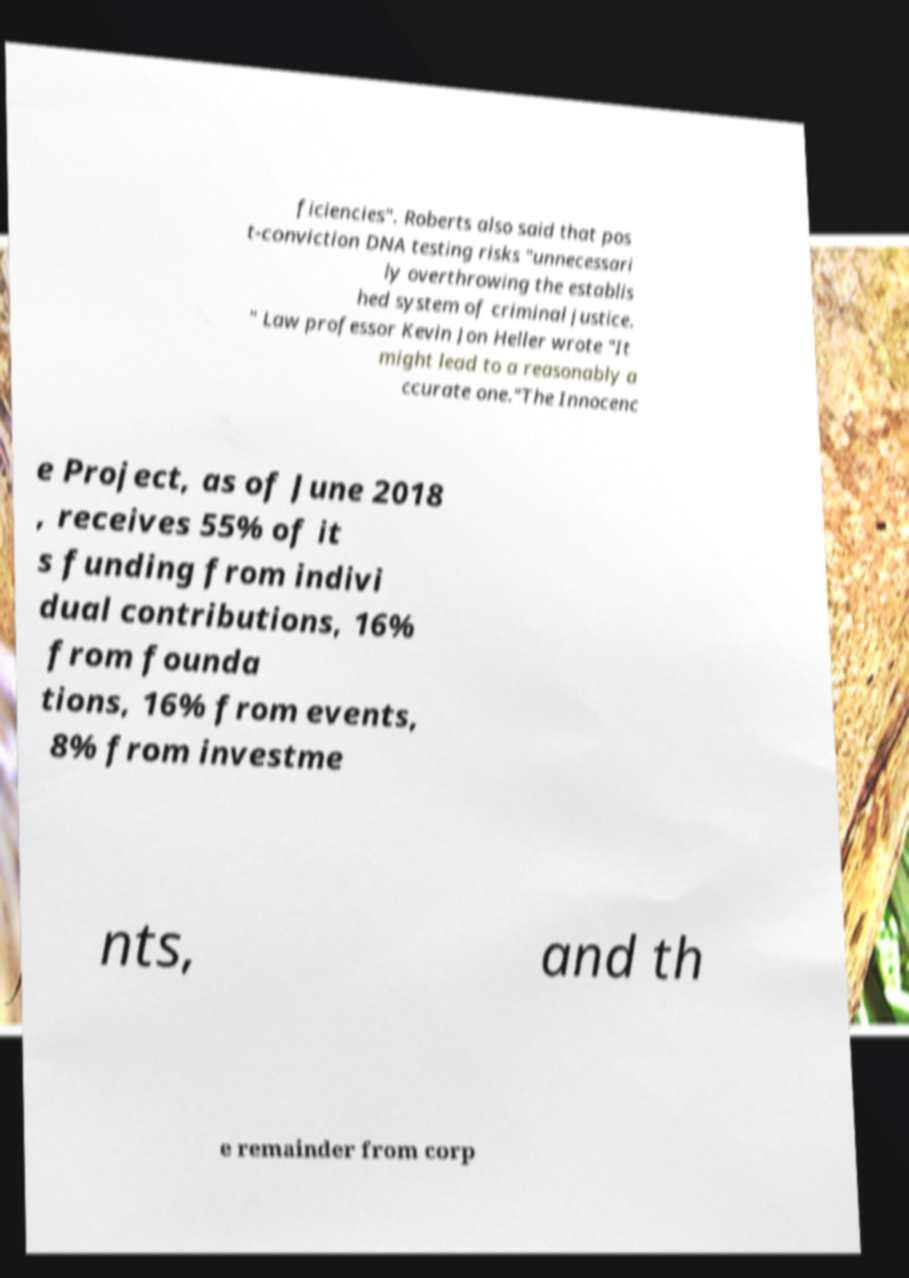Can you read and provide the text displayed in the image?This photo seems to have some interesting text. Can you extract and type it out for me? ficiencies". Roberts also said that pos t-conviction DNA testing risks "unnecessari ly overthrowing the establis hed system of criminal justice. " Law professor Kevin Jon Heller wrote "It might lead to a reasonably a ccurate one."The Innocenc e Project, as of June 2018 , receives 55% of it s funding from indivi dual contributions, 16% from founda tions, 16% from events, 8% from investme nts, and th e remainder from corp 